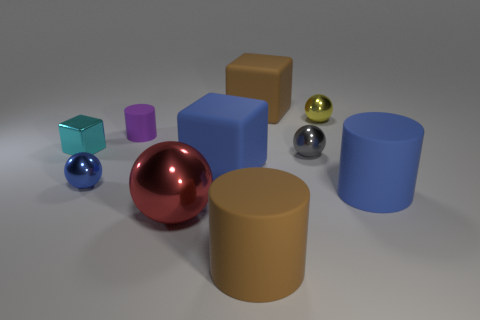What is the material of the tiny gray sphere?
Offer a terse response. Metal. What is the shape of the blue rubber object to the right of the large brown rubber cylinder?
Your answer should be compact. Cylinder. What is the color of the cube that is the same size as the purple object?
Your answer should be very brief. Cyan. Is the brown thing in front of the brown block made of the same material as the large blue block?
Keep it short and to the point. Yes. There is a ball that is both behind the blue shiny sphere and to the left of the yellow sphere; how big is it?
Offer a terse response. Small. There is a cyan object in front of the big brown matte block; what size is it?
Your response must be concise. Small. What is the shape of the small gray thing that is in front of the big brown matte object behind the tiny ball that is to the left of the blue block?
Your response must be concise. Sphere. What number of other things are there of the same shape as the purple matte thing?
Your response must be concise. 2. How many shiny objects are either red objects or big objects?
Your answer should be compact. 1. What material is the large blue thing that is behind the blue rubber thing that is in front of the blue metallic object made of?
Your response must be concise. Rubber. 